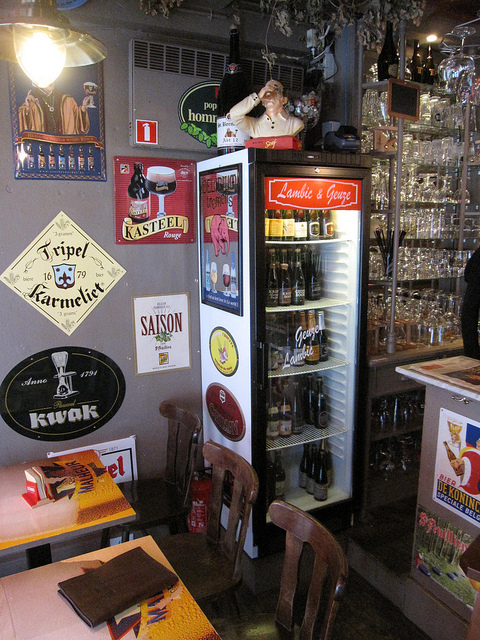What kinds of drinks are offered here based on the visible signs? The signage suggests a selection of Belgian beers, known for their rich tradition and distinct flavors. Brands like Tripel Karmeliet, Kasteel, and Saison are displayed, indicating that customers have a choice of high-quality, often craft-style beers. 